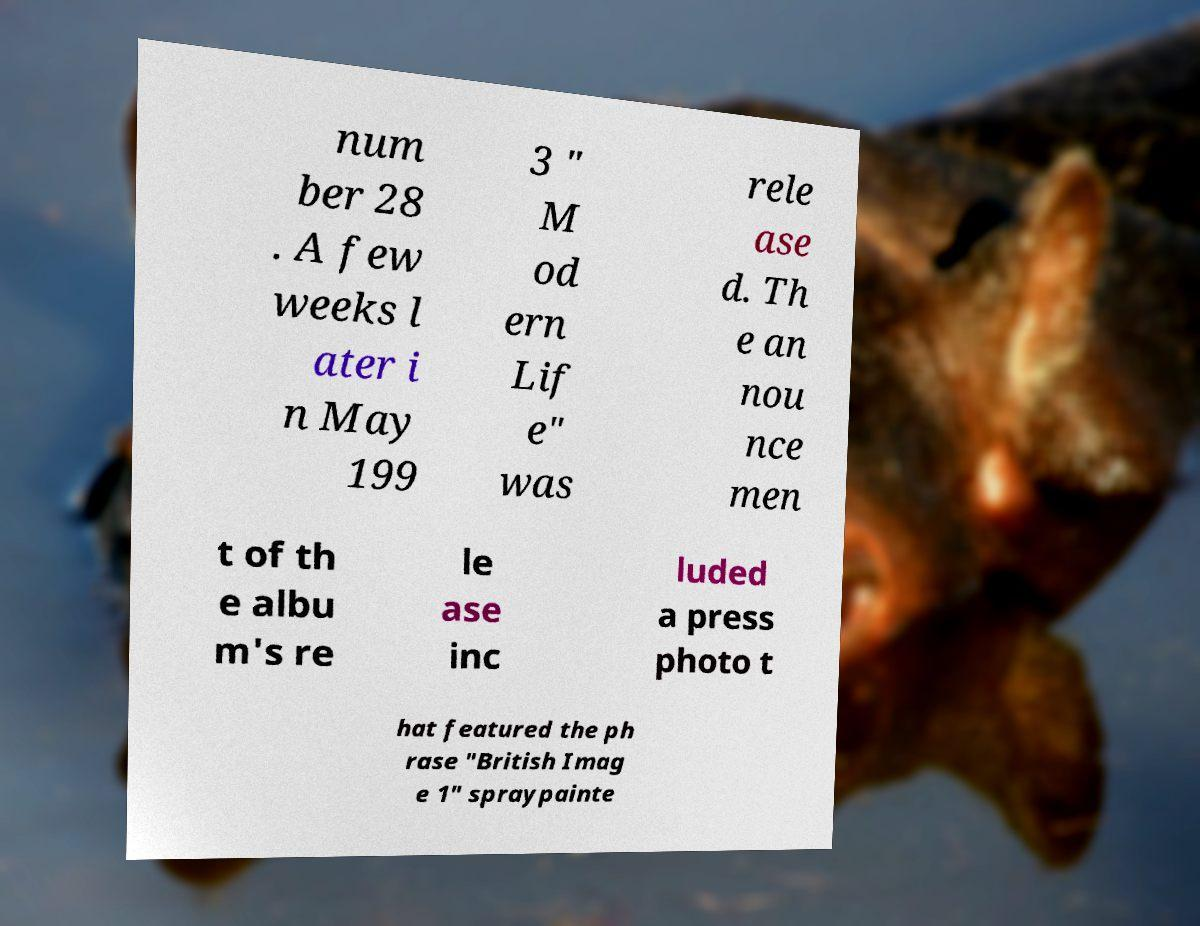Please identify and transcribe the text found in this image. num ber 28 . A few weeks l ater i n May 199 3 " M od ern Lif e" was rele ase d. Th e an nou nce men t of th e albu m's re le ase inc luded a press photo t hat featured the ph rase "British Imag e 1" spraypainte 